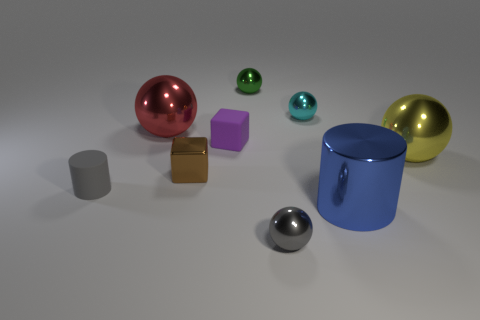What is the material of the other tiny thing that is the same shape as the tiny brown shiny object?
Provide a succinct answer. Rubber. How many other large things are the same shape as the big yellow thing?
Offer a very short reply. 1. Does the brown object have the same size as the gray object that is on the right side of the red thing?
Keep it short and to the point. Yes. Are there the same number of metal objects in front of the large yellow sphere and metal blocks on the right side of the blue metallic cylinder?
Offer a terse response. No. There is a small metal thing that is the same color as the matte cylinder; what shape is it?
Offer a very short reply. Sphere. What material is the small thing that is behind the cyan metal ball?
Your response must be concise. Metal. Is the size of the purple rubber cube the same as the red metallic sphere?
Your answer should be compact. No. Are there more tiny gray spheres behind the green object than big brown blocks?
Keep it short and to the point. No. There is a cyan thing that is made of the same material as the yellow object; what is its size?
Provide a short and direct response. Small. Are there any cubes behind the purple rubber object?
Your answer should be very brief. No. 